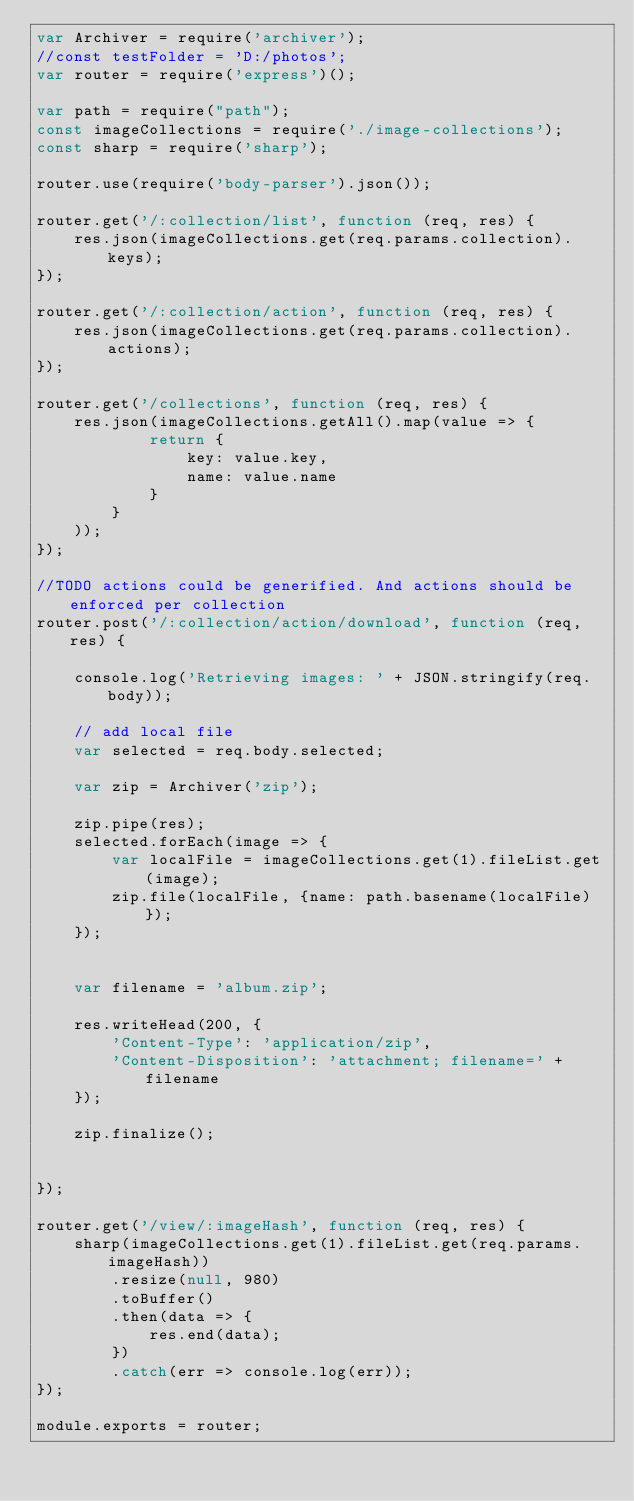Convert code to text. <code><loc_0><loc_0><loc_500><loc_500><_JavaScript_>var Archiver = require('archiver');
//const testFolder = 'D:/photos';
var router = require('express')();

var path = require("path");
const imageCollections = require('./image-collections');
const sharp = require('sharp');

router.use(require('body-parser').json());

router.get('/:collection/list', function (req, res) {
    res.json(imageCollections.get(req.params.collection).keys);
});

router.get('/:collection/action', function (req, res) {
    res.json(imageCollections.get(req.params.collection).actions);
});

router.get('/collections', function (req, res) {
    res.json(imageCollections.getAll().map(value => {
            return {
                key: value.key,
                name: value.name
            }
        }
    ));
});

//TODO actions could be generified. And actions should be enforced per collection
router.post('/:collection/action/download', function (req, res) {

    console.log('Retrieving images: ' + JSON.stringify(req.body));

    // add local file
    var selected = req.body.selected;

    var zip = Archiver('zip');

    zip.pipe(res);
    selected.forEach(image => {
        var localFile = imageCollections.get(1).fileList.get(image);
        zip.file(localFile, {name: path.basename(localFile)});
    });


    var filename = 'album.zip';

    res.writeHead(200, {
        'Content-Type': 'application/zip',
        'Content-Disposition': 'attachment; filename=' + filename
    });

    zip.finalize();


});

router.get('/view/:imageHash', function (req, res) {
    sharp(imageCollections.get(1).fileList.get(req.params.imageHash))
        .resize(null, 980)
        .toBuffer()
        .then(data => {
            res.end(data);
        })
        .catch(err => console.log(err));
});

module.exports = router;
</code> 